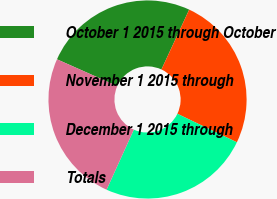Convert chart to OTSL. <chart><loc_0><loc_0><loc_500><loc_500><pie_chart><fcel>October 1 2015 through October<fcel>November 1 2015 through<fcel>December 1 2015 through<fcel>Totals<nl><fcel>25.26%<fcel>25.2%<fcel>24.67%<fcel>24.87%<nl></chart> 